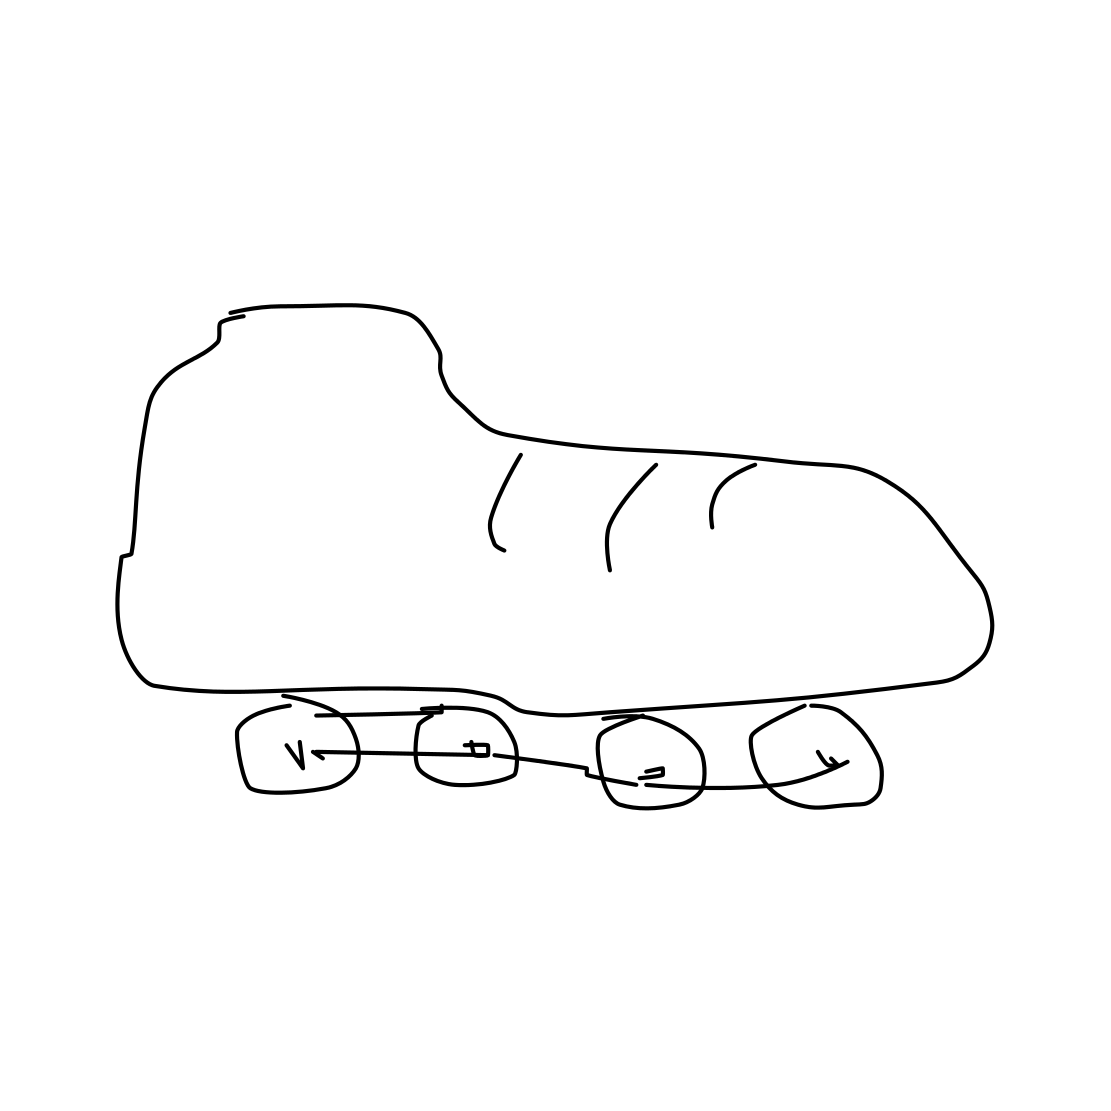Is there a sketchy rollerblades in the picture? Yes, the image indeed shows a sketch of rollerblades, featuring clearly visible wheels and a boot. The style is simplistic yet distinct, highlighting the essential components of the rollerblades. 